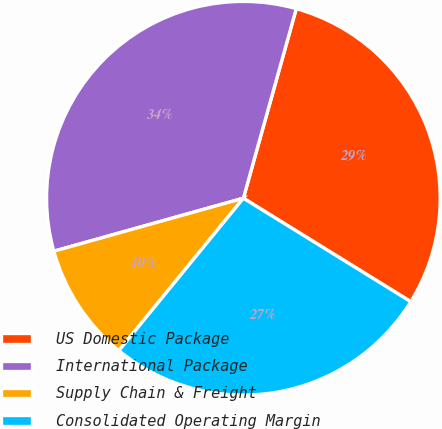<chart> <loc_0><loc_0><loc_500><loc_500><pie_chart><fcel>US Domestic Package<fcel>International Package<fcel>Supply Chain & Freight<fcel>Consolidated Operating Margin<nl><fcel>29.48%<fcel>33.67%<fcel>9.76%<fcel>27.09%<nl></chart> 